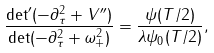Convert formula to latex. <formula><loc_0><loc_0><loc_500><loc_500>\frac { \det ^ { \prime } ( - \partial _ { \tau } ^ { 2 } + V ^ { \prime \prime } ) } { \det ( - \partial _ { \tau } ^ { 2 } + \omega _ { + } ^ { 2 } ) } = \frac { \psi ( T / 2 ) } { \lambda \psi _ { 0 } ( T / 2 ) } ,</formula> 